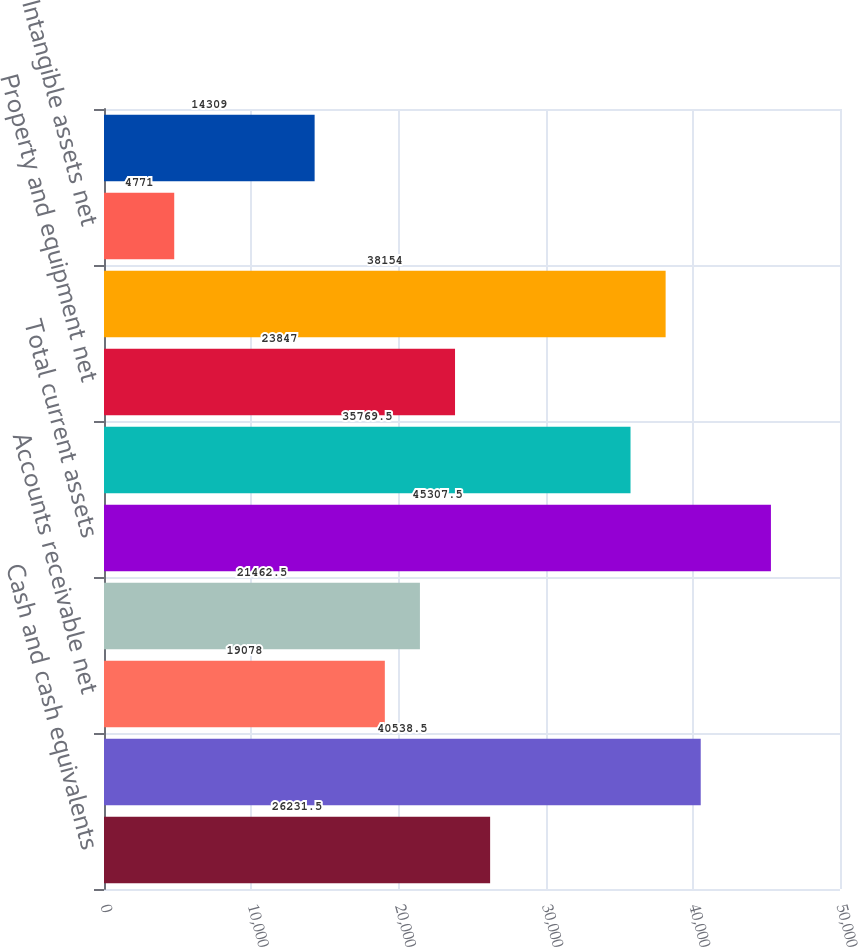Convert chart to OTSL. <chart><loc_0><loc_0><loc_500><loc_500><bar_chart><fcel>Cash and cash equivalents<fcel>Short-term investments<fcel>Accounts receivable net<fcel>Other current assets<fcel>Total current assets<fcel>Long-term investments<fcel>Property and equipment net<fcel>Goodwill<fcel>Intangible assets net<fcel>Other assets<nl><fcel>26231.5<fcel>40538.5<fcel>19078<fcel>21462.5<fcel>45307.5<fcel>35769.5<fcel>23847<fcel>38154<fcel>4771<fcel>14309<nl></chart> 